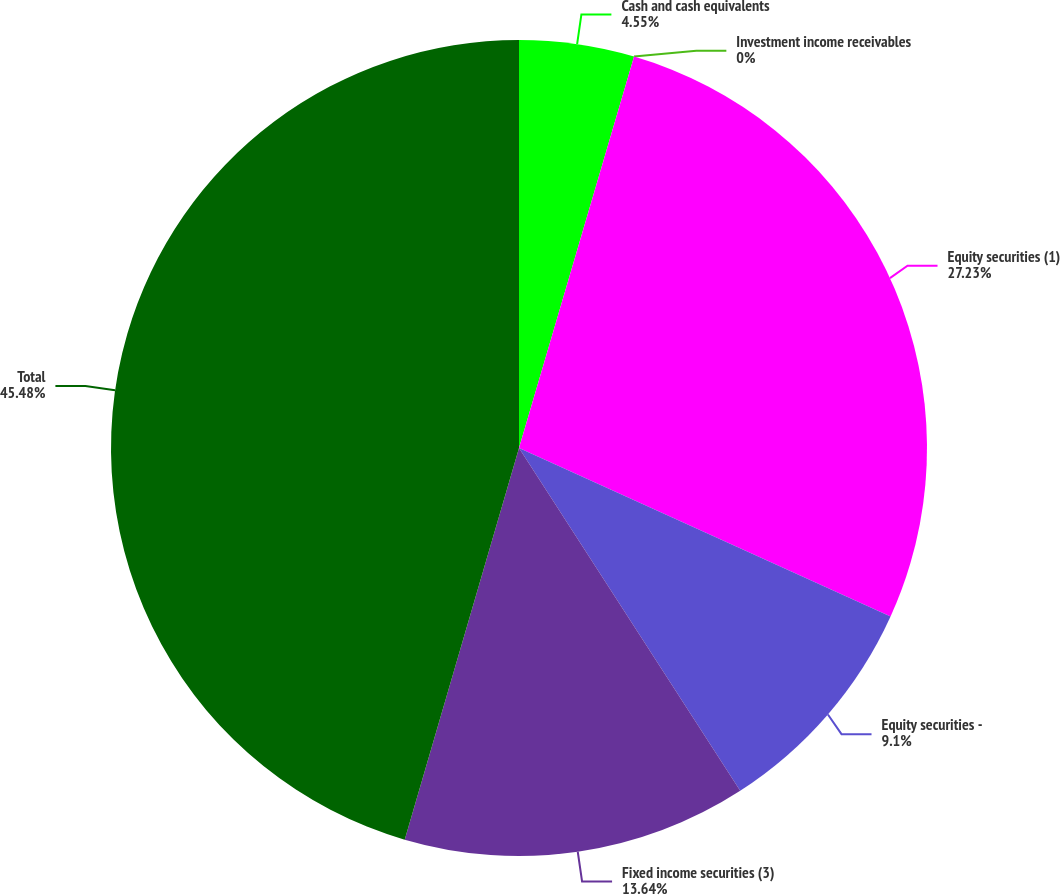Convert chart to OTSL. <chart><loc_0><loc_0><loc_500><loc_500><pie_chart><fcel>Cash and cash equivalents<fcel>Investment income receivables<fcel>Equity securities (1)<fcel>Equity securities -<fcel>Fixed income securities (3)<fcel>Total<nl><fcel>4.55%<fcel>0.0%<fcel>27.23%<fcel>9.1%<fcel>13.64%<fcel>45.48%<nl></chart> 